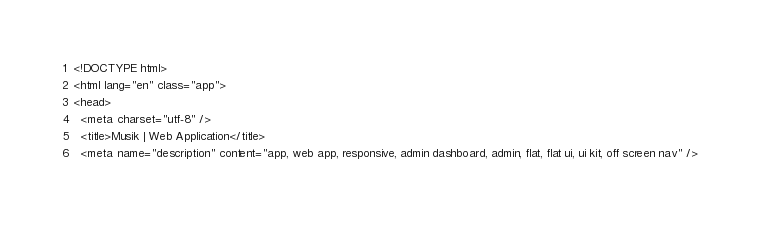<code> <loc_0><loc_0><loc_500><loc_500><_HTML_><!DOCTYPE html>
<html lang="en" class="app">
<head>  
  <meta charset="utf-8" />
  <title>Musik | Web Application</title>
  <meta name="description" content="app, web app, responsive, admin dashboard, admin, flat, flat ui, ui kit, off screen nav" /></code> 